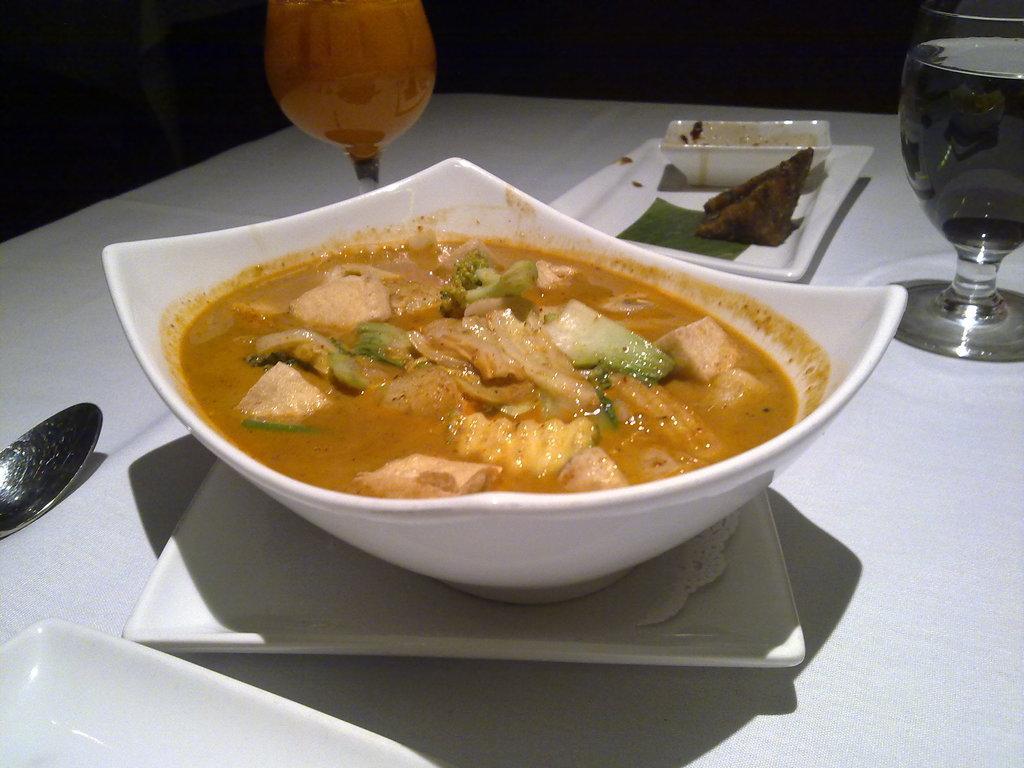In one or two sentences, can you explain what this image depicts? Background portion of the picture is completely dark. In this picture we can see a table. On a table we can see food, plates, spoon, water glass and objects. We can see juice in a glass. 